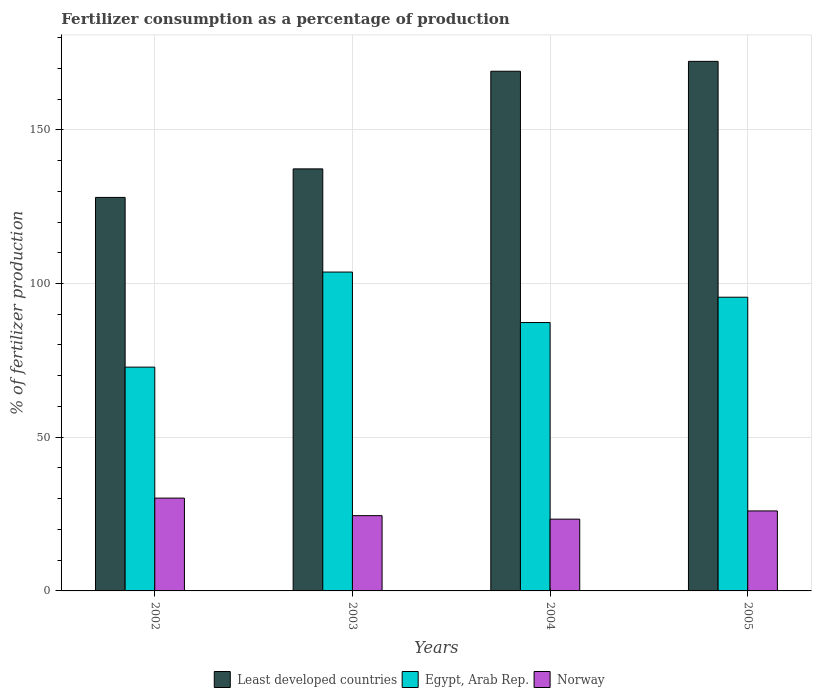How many different coloured bars are there?
Your answer should be compact. 3. Are the number of bars per tick equal to the number of legend labels?
Make the answer very short. Yes. What is the percentage of fertilizers consumed in Least developed countries in 2003?
Your answer should be compact. 137.28. Across all years, what is the maximum percentage of fertilizers consumed in Norway?
Offer a terse response. 30.19. Across all years, what is the minimum percentage of fertilizers consumed in Egypt, Arab Rep.?
Provide a succinct answer. 72.8. In which year was the percentage of fertilizers consumed in Least developed countries minimum?
Offer a very short reply. 2002. What is the total percentage of fertilizers consumed in Norway in the graph?
Offer a terse response. 104.04. What is the difference between the percentage of fertilizers consumed in Least developed countries in 2002 and that in 2004?
Your response must be concise. -41.04. What is the difference between the percentage of fertilizers consumed in Egypt, Arab Rep. in 2005 and the percentage of fertilizers consumed in Norway in 2004?
Keep it short and to the point. 72.19. What is the average percentage of fertilizers consumed in Egypt, Arab Rep. per year?
Your answer should be very brief. 89.84. In the year 2002, what is the difference between the percentage of fertilizers consumed in Norway and percentage of fertilizers consumed in Egypt, Arab Rep.?
Your response must be concise. -42.6. What is the ratio of the percentage of fertilizers consumed in Norway in 2003 to that in 2005?
Offer a very short reply. 0.94. Is the difference between the percentage of fertilizers consumed in Norway in 2002 and 2004 greater than the difference between the percentage of fertilizers consumed in Egypt, Arab Rep. in 2002 and 2004?
Keep it short and to the point. Yes. What is the difference between the highest and the second highest percentage of fertilizers consumed in Norway?
Ensure brevity in your answer.  4.18. What is the difference between the highest and the lowest percentage of fertilizers consumed in Egypt, Arab Rep.?
Provide a short and direct response. 30.92. Is the sum of the percentage of fertilizers consumed in Norway in 2002 and 2005 greater than the maximum percentage of fertilizers consumed in Egypt, Arab Rep. across all years?
Your response must be concise. No. What does the 1st bar from the left in 2005 represents?
Provide a succinct answer. Least developed countries. What does the 3rd bar from the right in 2002 represents?
Ensure brevity in your answer.  Least developed countries. Is it the case that in every year, the sum of the percentage of fertilizers consumed in Egypt, Arab Rep. and percentage of fertilizers consumed in Norway is greater than the percentage of fertilizers consumed in Least developed countries?
Your answer should be compact. No. How many bars are there?
Your answer should be compact. 12. Are all the bars in the graph horizontal?
Your answer should be very brief. No. How many years are there in the graph?
Give a very brief answer. 4. What is the difference between two consecutive major ticks on the Y-axis?
Keep it short and to the point. 50. Does the graph contain any zero values?
Your response must be concise. No. Does the graph contain grids?
Ensure brevity in your answer.  Yes. Where does the legend appear in the graph?
Provide a short and direct response. Bottom center. What is the title of the graph?
Your response must be concise. Fertilizer consumption as a percentage of production. Does "Luxembourg" appear as one of the legend labels in the graph?
Ensure brevity in your answer.  No. What is the label or title of the Y-axis?
Offer a very short reply. % of fertilizer production. What is the % of fertilizer production in Least developed countries in 2002?
Give a very brief answer. 128. What is the % of fertilizer production of Egypt, Arab Rep. in 2002?
Provide a short and direct response. 72.8. What is the % of fertilizer production in Norway in 2002?
Provide a succinct answer. 30.19. What is the % of fertilizer production of Least developed countries in 2003?
Offer a very short reply. 137.28. What is the % of fertilizer production in Egypt, Arab Rep. in 2003?
Give a very brief answer. 103.72. What is the % of fertilizer production of Norway in 2003?
Your response must be concise. 24.48. What is the % of fertilizer production in Least developed countries in 2004?
Make the answer very short. 169.04. What is the % of fertilizer production in Egypt, Arab Rep. in 2004?
Provide a succinct answer. 87.3. What is the % of fertilizer production of Norway in 2004?
Provide a short and direct response. 23.34. What is the % of fertilizer production in Least developed countries in 2005?
Give a very brief answer. 172.25. What is the % of fertilizer production of Egypt, Arab Rep. in 2005?
Your response must be concise. 95.53. What is the % of fertilizer production of Norway in 2005?
Make the answer very short. 26.02. Across all years, what is the maximum % of fertilizer production in Least developed countries?
Keep it short and to the point. 172.25. Across all years, what is the maximum % of fertilizer production of Egypt, Arab Rep.?
Keep it short and to the point. 103.72. Across all years, what is the maximum % of fertilizer production of Norway?
Keep it short and to the point. 30.19. Across all years, what is the minimum % of fertilizer production in Least developed countries?
Your response must be concise. 128. Across all years, what is the minimum % of fertilizer production in Egypt, Arab Rep.?
Make the answer very short. 72.8. Across all years, what is the minimum % of fertilizer production of Norway?
Ensure brevity in your answer.  23.34. What is the total % of fertilizer production in Least developed countries in the graph?
Offer a terse response. 606.57. What is the total % of fertilizer production in Egypt, Arab Rep. in the graph?
Your answer should be very brief. 359.35. What is the total % of fertilizer production of Norway in the graph?
Offer a terse response. 104.04. What is the difference between the % of fertilizer production of Least developed countries in 2002 and that in 2003?
Give a very brief answer. -9.28. What is the difference between the % of fertilizer production of Egypt, Arab Rep. in 2002 and that in 2003?
Give a very brief answer. -30.92. What is the difference between the % of fertilizer production of Norway in 2002 and that in 2003?
Keep it short and to the point. 5.71. What is the difference between the % of fertilizer production in Least developed countries in 2002 and that in 2004?
Your response must be concise. -41.04. What is the difference between the % of fertilizer production of Egypt, Arab Rep. in 2002 and that in 2004?
Make the answer very short. -14.5. What is the difference between the % of fertilizer production of Norway in 2002 and that in 2004?
Your answer should be compact. 6.85. What is the difference between the % of fertilizer production of Least developed countries in 2002 and that in 2005?
Provide a short and direct response. -44.26. What is the difference between the % of fertilizer production of Egypt, Arab Rep. in 2002 and that in 2005?
Offer a terse response. -22.74. What is the difference between the % of fertilizer production of Norway in 2002 and that in 2005?
Ensure brevity in your answer.  4.18. What is the difference between the % of fertilizer production of Least developed countries in 2003 and that in 2004?
Provide a short and direct response. -31.76. What is the difference between the % of fertilizer production in Egypt, Arab Rep. in 2003 and that in 2004?
Your answer should be very brief. 16.42. What is the difference between the % of fertilizer production in Norway in 2003 and that in 2004?
Provide a short and direct response. 1.14. What is the difference between the % of fertilizer production in Least developed countries in 2003 and that in 2005?
Keep it short and to the point. -34.97. What is the difference between the % of fertilizer production of Egypt, Arab Rep. in 2003 and that in 2005?
Your response must be concise. 8.18. What is the difference between the % of fertilizer production of Norway in 2003 and that in 2005?
Give a very brief answer. -1.53. What is the difference between the % of fertilizer production in Least developed countries in 2004 and that in 2005?
Give a very brief answer. -3.22. What is the difference between the % of fertilizer production in Egypt, Arab Rep. in 2004 and that in 2005?
Ensure brevity in your answer.  -8.24. What is the difference between the % of fertilizer production in Norway in 2004 and that in 2005?
Give a very brief answer. -2.67. What is the difference between the % of fertilizer production in Least developed countries in 2002 and the % of fertilizer production in Egypt, Arab Rep. in 2003?
Keep it short and to the point. 24.28. What is the difference between the % of fertilizer production of Least developed countries in 2002 and the % of fertilizer production of Norway in 2003?
Provide a succinct answer. 103.51. What is the difference between the % of fertilizer production in Egypt, Arab Rep. in 2002 and the % of fertilizer production in Norway in 2003?
Offer a very short reply. 48.31. What is the difference between the % of fertilizer production of Least developed countries in 2002 and the % of fertilizer production of Egypt, Arab Rep. in 2004?
Your answer should be compact. 40.7. What is the difference between the % of fertilizer production of Least developed countries in 2002 and the % of fertilizer production of Norway in 2004?
Your answer should be very brief. 104.65. What is the difference between the % of fertilizer production of Egypt, Arab Rep. in 2002 and the % of fertilizer production of Norway in 2004?
Your answer should be compact. 49.45. What is the difference between the % of fertilizer production of Least developed countries in 2002 and the % of fertilizer production of Egypt, Arab Rep. in 2005?
Provide a short and direct response. 32.46. What is the difference between the % of fertilizer production of Least developed countries in 2002 and the % of fertilizer production of Norway in 2005?
Offer a terse response. 101.98. What is the difference between the % of fertilizer production of Egypt, Arab Rep. in 2002 and the % of fertilizer production of Norway in 2005?
Make the answer very short. 46.78. What is the difference between the % of fertilizer production in Least developed countries in 2003 and the % of fertilizer production in Egypt, Arab Rep. in 2004?
Make the answer very short. 49.98. What is the difference between the % of fertilizer production in Least developed countries in 2003 and the % of fertilizer production in Norway in 2004?
Your answer should be compact. 113.94. What is the difference between the % of fertilizer production in Egypt, Arab Rep. in 2003 and the % of fertilizer production in Norway in 2004?
Keep it short and to the point. 80.38. What is the difference between the % of fertilizer production in Least developed countries in 2003 and the % of fertilizer production in Egypt, Arab Rep. in 2005?
Make the answer very short. 41.75. What is the difference between the % of fertilizer production in Least developed countries in 2003 and the % of fertilizer production in Norway in 2005?
Give a very brief answer. 111.26. What is the difference between the % of fertilizer production of Egypt, Arab Rep. in 2003 and the % of fertilizer production of Norway in 2005?
Offer a terse response. 77.7. What is the difference between the % of fertilizer production in Least developed countries in 2004 and the % of fertilizer production in Egypt, Arab Rep. in 2005?
Make the answer very short. 73.5. What is the difference between the % of fertilizer production in Least developed countries in 2004 and the % of fertilizer production in Norway in 2005?
Offer a terse response. 143.02. What is the difference between the % of fertilizer production of Egypt, Arab Rep. in 2004 and the % of fertilizer production of Norway in 2005?
Your answer should be very brief. 61.28. What is the average % of fertilizer production in Least developed countries per year?
Ensure brevity in your answer.  151.64. What is the average % of fertilizer production of Egypt, Arab Rep. per year?
Provide a succinct answer. 89.84. What is the average % of fertilizer production of Norway per year?
Your response must be concise. 26.01. In the year 2002, what is the difference between the % of fertilizer production of Least developed countries and % of fertilizer production of Egypt, Arab Rep.?
Your answer should be very brief. 55.2. In the year 2002, what is the difference between the % of fertilizer production of Least developed countries and % of fertilizer production of Norway?
Keep it short and to the point. 97.8. In the year 2002, what is the difference between the % of fertilizer production in Egypt, Arab Rep. and % of fertilizer production in Norway?
Give a very brief answer. 42.6. In the year 2003, what is the difference between the % of fertilizer production of Least developed countries and % of fertilizer production of Egypt, Arab Rep.?
Your response must be concise. 33.56. In the year 2003, what is the difference between the % of fertilizer production in Least developed countries and % of fertilizer production in Norway?
Your response must be concise. 112.8. In the year 2003, what is the difference between the % of fertilizer production in Egypt, Arab Rep. and % of fertilizer production in Norway?
Provide a short and direct response. 79.24. In the year 2004, what is the difference between the % of fertilizer production in Least developed countries and % of fertilizer production in Egypt, Arab Rep.?
Provide a succinct answer. 81.74. In the year 2004, what is the difference between the % of fertilizer production of Least developed countries and % of fertilizer production of Norway?
Offer a very short reply. 145.69. In the year 2004, what is the difference between the % of fertilizer production of Egypt, Arab Rep. and % of fertilizer production of Norway?
Make the answer very short. 63.96. In the year 2005, what is the difference between the % of fertilizer production of Least developed countries and % of fertilizer production of Egypt, Arab Rep.?
Your answer should be compact. 76.72. In the year 2005, what is the difference between the % of fertilizer production in Least developed countries and % of fertilizer production in Norway?
Your answer should be compact. 146.24. In the year 2005, what is the difference between the % of fertilizer production in Egypt, Arab Rep. and % of fertilizer production in Norway?
Keep it short and to the point. 69.52. What is the ratio of the % of fertilizer production in Least developed countries in 2002 to that in 2003?
Your answer should be very brief. 0.93. What is the ratio of the % of fertilizer production in Egypt, Arab Rep. in 2002 to that in 2003?
Your answer should be compact. 0.7. What is the ratio of the % of fertilizer production in Norway in 2002 to that in 2003?
Provide a short and direct response. 1.23. What is the ratio of the % of fertilizer production in Least developed countries in 2002 to that in 2004?
Ensure brevity in your answer.  0.76. What is the ratio of the % of fertilizer production in Egypt, Arab Rep. in 2002 to that in 2004?
Offer a very short reply. 0.83. What is the ratio of the % of fertilizer production in Norway in 2002 to that in 2004?
Offer a very short reply. 1.29. What is the ratio of the % of fertilizer production in Least developed countries in 2002 to that in 2005?
Provide a short and direct response. 0.74. What is the ratio of the % of fertilizer production in Egypt, Arab Rep. in 2002 to that in 2005?
Your answer should be compact. 0.76. What is the ratio of the % of fertilizer production in Norway in 2002 to that in 2005?
Provide a short and direct response. 1.16. What is the ratio of the % of fertilizer production of Least developed countries in 2003 to that in 2004?
Your answer should be very brief. 0.81. What is the ratio of the % of fertilizer production in Egypt, Arab Rep. in 2003 to that in 2004?
Keep it short and to the point. 1.19. What is the ratio of the % of fertilizer production in Norway in 2003 to that in 2004?
Provide a succinct answer. 1.05. What is the ratio of the % of fertilizer production of Least developed countries in 2003 to that in 2005?
Provide a succinct answer. 0.8. What is the ratio of the % of fertilizer production in Egypt, Arab Rep. in 2003 to that in 2005?
Provide a short and direct response. 1.09. What is the ratio of the % of fertilizer production of Norway in 2003 to that in 2005?
Keep it short and to the point. 0.94. What is the ratio of the % of fertilizer production of Least developed countries in 2004 to that in 2005?
Offer a very short reply. 0.98. What is the ratio of the % of fertilizer production in Egypt, Arab Rep. in 2004 to that in 2005?
Provide a short and direct response. 0.91. What is the ratio of the % of fertilizer production of Norway in 2004 to that in 2005?
Make the answer very short. 0.9. What is the difference between the highest and the second highest % of fertilizer production in Least developed countries?
Give a very brief answer. 3.22. What is the difference between the highest and the second highest % of fertilizer production in Egypt, Arab Rep.?
Your answer should be compact. 8.18. What is the difference between the highest and the second highest % of fertilizer production in Norway?
Offer a very short reply. 4.18. What is the difference between the highest and the lowest % of fertilizer production in Least developed countries?
Provide a short and direct response. 44.26. What is the difference between the highest and the lowest % of fertilizer production of Egypt, Arab Rep.?
Your answer should be compact. 30.92. What is the difference between the highest and the lowest % of fertilizer production in Norway?
Keep it short and to the point. 6.85. 